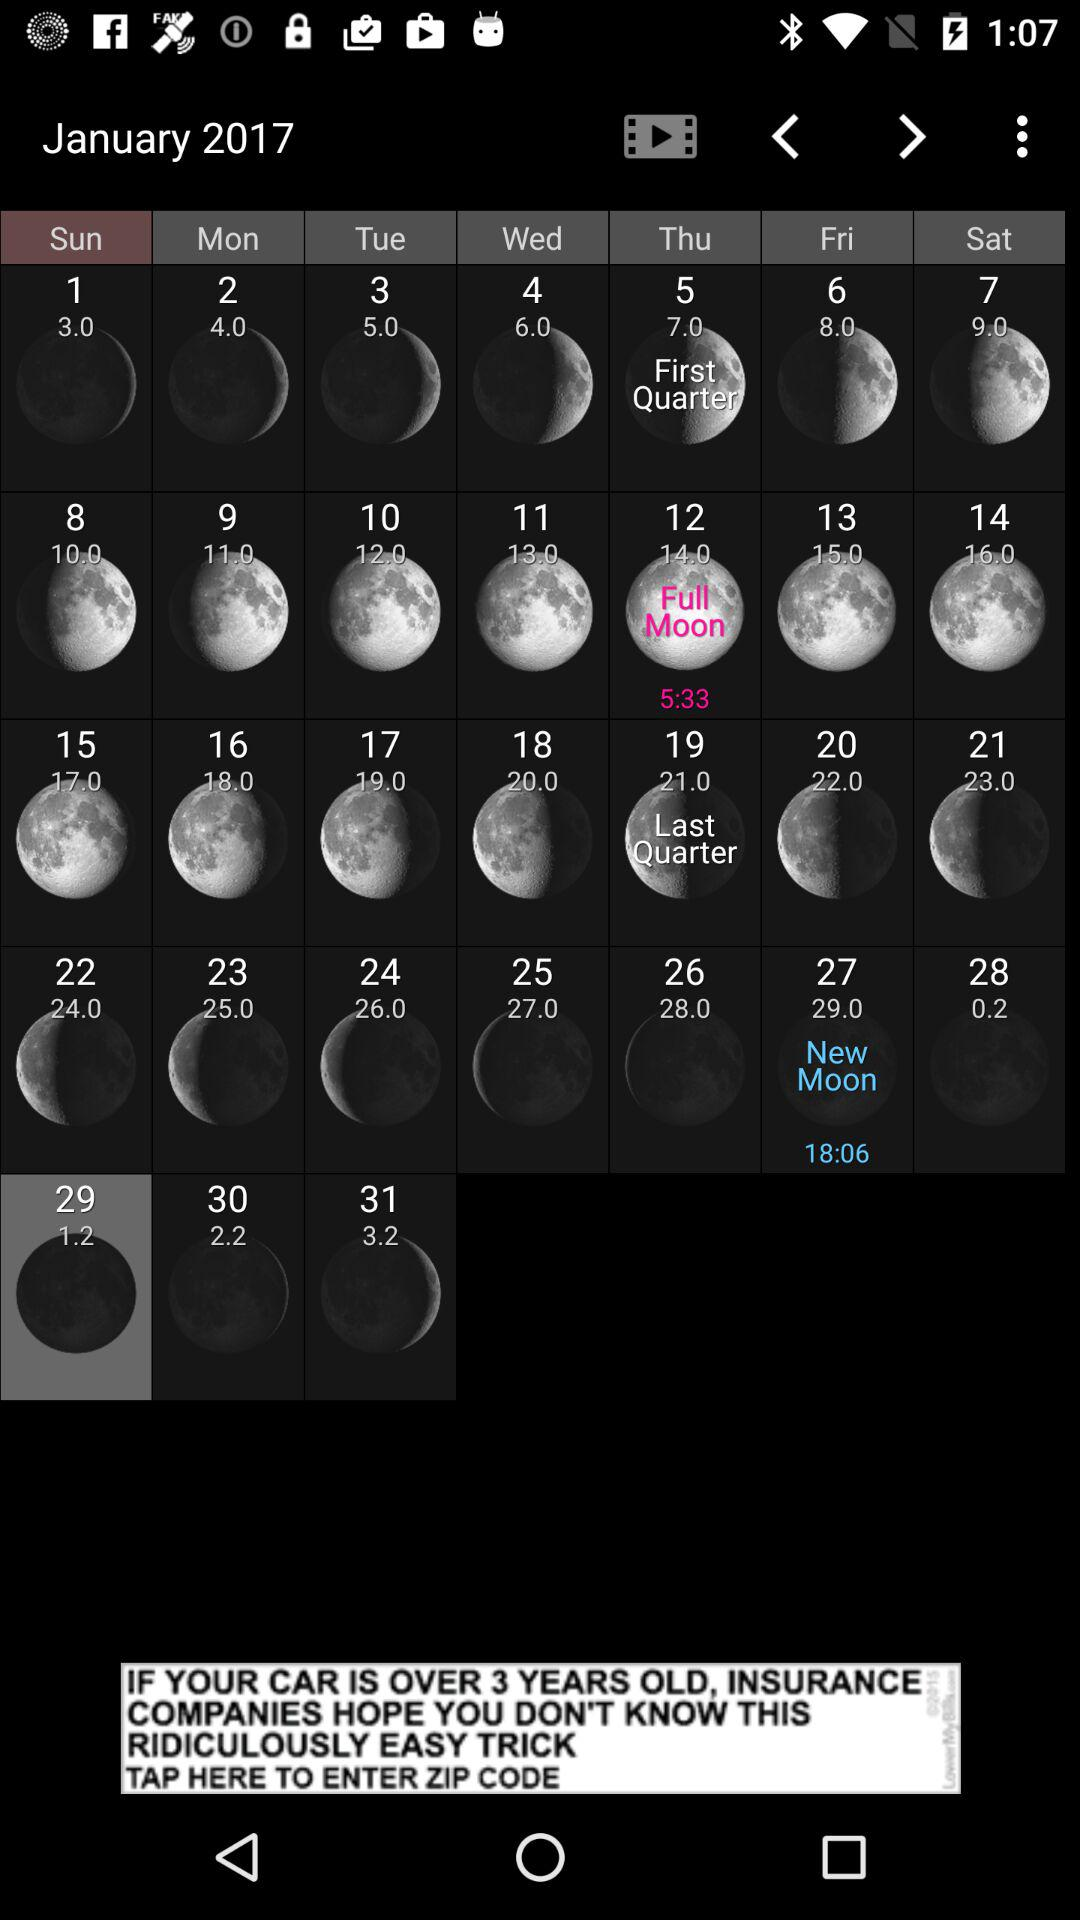What's the full moon date? The full moon date is Thursday, January 12, 2017. 